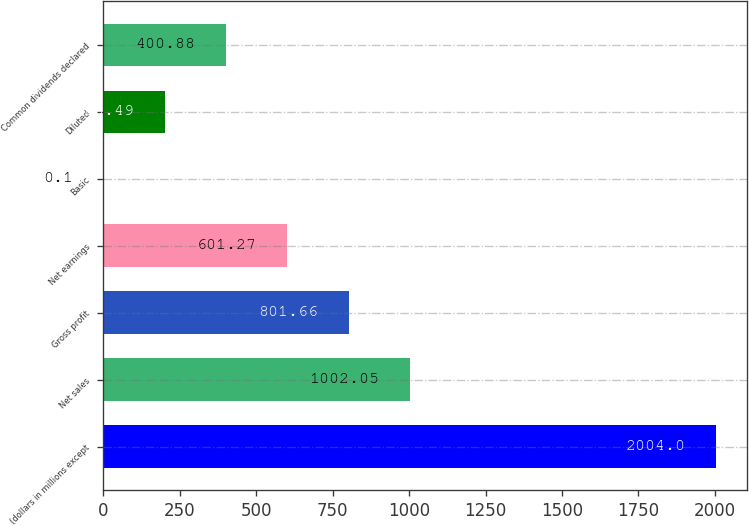<chart> <loc_0><loc_0><loc_500><loc_500><bar_chart><fcel>(dollars in millions except<fcel>Net sales<fcel>Gross profit<fcel>Net earnings<fcel>Basic<fcel>Diluted<fcel>Common dividends declared<nl><fcel>2004<fcel>1002.05<fcel>801.66<fcel>601.27<fcel>0.1<fcel>200.49<fcel>400.88<nl></chart> 